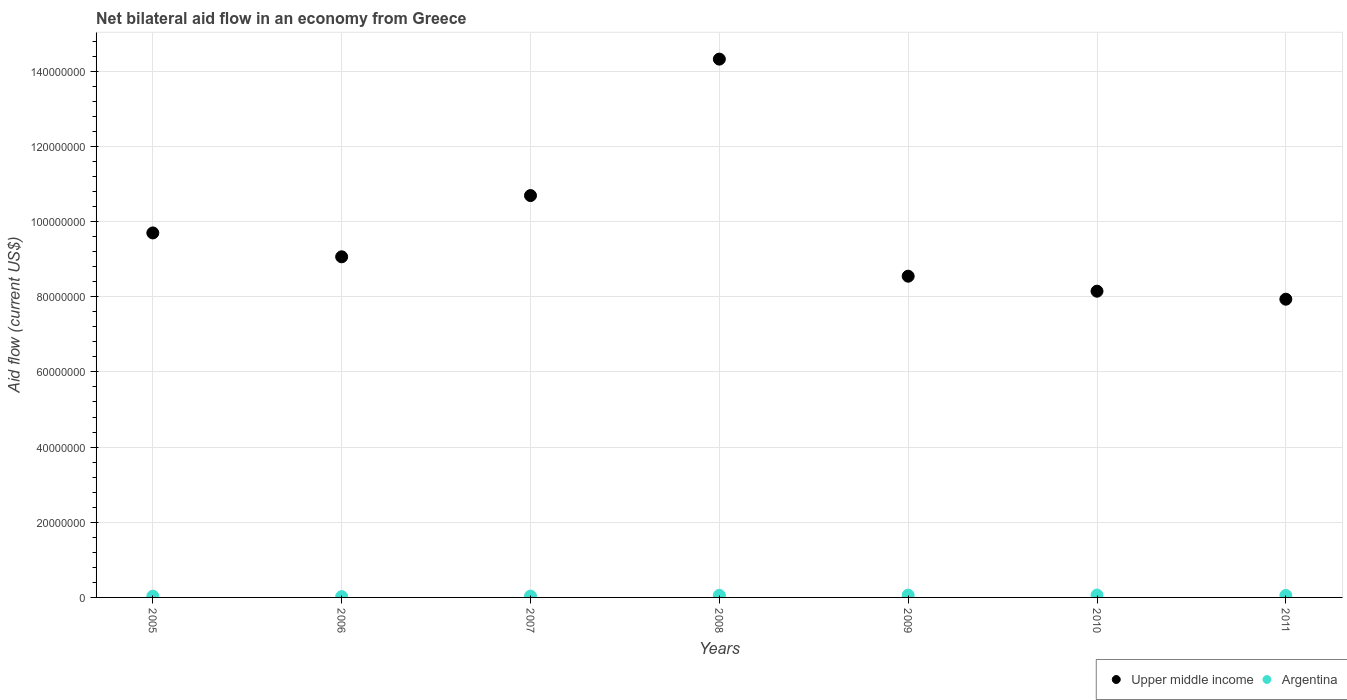Is the number of dotlines equal to the number of legend labels?
Provide a short and direct response. Yes. What is the net bilateral aid flow in Argentina in 2011?
Your answer should be compact. 5.20e+05. Across all years, what is the maximum net bilateral aid flow in Upper middle income?
Give a very brief answer. 1.43e+08. Across all years, what is the minimum net bilateral aid flow in Upper middle income?
Provide a short and direct response. 7.93e+07. What is the total net bilateral aid flow in Argentina in the graph?
Ensure brevity in your answer.  3.20e+06. What is the difference between the net bilateral aid flow in Upper middle income in 2006 and that in 2009?
Provide a succinct answer. 5.16e+06. What is the difference between the net bilateral aid flow in Upper middle income in 2007 and the net bilateral aid flow in Argentina in 2010?
Ensure brevity in your answer.  1.06e+08. What is the average net bilateral aid flow in Upper middle income per year?
Offer a very short reply. 9.77e+07. In the year 2011, what is the difference between the net bilateral aid flow in Argentina and net bilateral aid flow in Upper middle income?
Ensure brevity in your answer.  -7.88e+07. What is the ratio of the net bilateral aid flow in Argentina in 2008 to that in 2009?
Keep it short and to the point. 0.9. Is the difference between the net bilateral aid flow in Argentina in 2009 and 2010 greater than the difference between the net bilateral aid flow in Upper middle income in 2009 and 2010?
Your answer should be compact. No. What is the difference between the highest and the second highest net bilateral aid flow in Upper middle income?
Keep it short and to the point. 3.63e+07. What is the difference between the highest and the lowest net bilateral aid flow in Argentina?
Offer a very short reply. 4.10e+05. In how many years, is the net bilateral aid flow in Argentina greater than the average net bilateral aid flow in Argentina taken over all years?
Your answer should be compact. 4. Is the net bilateral aid flow in Argentina strictly greater than the net bilateral aid flow in Upper middle income over the years?
Offer a very short reply. No. Is the net bilateral aid flow in Upper middle income strictly less than the net bilateral aid flow in Argentina over the years?
Your answer should be compact. No. How many dotlines are there?
Ensure brevity in your answer.  2. How many years are there in the graph?
Your answer should be compact. 7. Does the graph contain any zero values?
Your answer should be very brief. No. What is the title of the graph?
Offer a very short reply. Net bilateral aid flow in an economy from Greece. Does "World" appear as one of the legend labels in the graph?
Your response must be concise. No. What is the label or title of the X-axis?
Your response must be concise. Years. What is the label or title of the Y-axis?
Offer a very short reply. Aid flow (current US$). What is the Aid flow (current US$) of Upper middle income in 2005?
Offer a very short reply. 9.70e+07. What is the Aid flow (current US$) in Upper middle income in 2006?
Provide a short and direct response. 9.06e+07. What is the Aid flow (current US$) in Argentina in 2006?
Your response must be concise. 2.20e+05. What is the Aid flow (current US$) of Upper middle income in 2007?
Ensure brevity in your answer.  1.07e+08. What is the Aid flow (current US$) of Upper middle income in 2008?
Provide a succinct answer. 1.43e+08. What is the Aid flow (current US$) in Upper middle income in 2009?
Your response must be concise. 8.55e+07. What is the Aid flow (current US$) of Argentina in 2009?
Ensure brevity in your answer.  6.10e+05. What is the Aid flow (current US$) in Upper middle income in 2010?
Give a very brief answer. 8.15e+07. What is the Aid flow (current US$) of Argentina in 2010?
Keep it short and to the point. 6.30e+05. What is the Aid flow (current US$) in Upper middle income in 2011?
Keep it short and to the point. 7.93e+07. What is the Aid flow (current US$) in Argentina in 2011?
Provide a short and direct response. 5.20e+05. Across all years, what is the maximum Aid flow (current US$) in Upper middle income?
Your response must be concise. 1.43e+08. Across all years, what is the maximum Aid flow (current US$) of Argentina?
Provide a short and direct response. 6.30e+05. Across all years, what is the minimum Aid flow (current US$) in Upper middle income?
Make the answer very short. 7.93e+07. Across all years, what is the minimum Aid flow (current US$) in Argentina?
Ensure brevity in your answer.  2.20e+05. What is the total Aid flow (current US$) in Upper middle income in the graph?
Your answer should be compact. 6.84e+08. What is the total Aid flow (current US$) in Argentina in the graph?
Ensure brevity in your answer.  3.20e+06. What is the difference between the Aid flow (current US$) of Upper middle income in 2005 and that in 2006?
Your answer should be compact. 6.35e+06. What is the difference between the Aid flow (current US$) of Upper middle income in 2005 and that in 2007?
Your response must be concise. -9.94e+06. What is the difference between the Aid flow (current US$) of Argentina in 2005 and that in 2007?
Make the answer very short. -3.00e+04. What is the difference between the Aid flow (current US$) in Upper middle income in 2005 and that in 2008?
Give a very brief answer. -4.62e+07. What is the difference between the Aid flow (current US$) of Argentina in 2005 and that in 2008?
Give a very brief answer. -2.30e+05. What is the difference between the Aid flow (current US$) in Upper middle income in 2005 and that in 2009?
Your response must be concise. 1.15e+07. What is the difference between the Aid flow (current US$) of Argentina in 2005 and that in 2009?
Your answer should be very brief. -2.90e+05. What is the difference between the Aid flow (current US$) in Upper middle income in 2005 and that in 2010?
Provide a succinct answer. 1.55e+07. What is the difference between the Aid flow (current US$) in Argentina in 2005 and that in 2010?
Offer a very short reply. -3.10e+05. What is the difference between the Aid flow (current US$) in Upper middle income in 2005 and that in 2011?
Make the answer very short. 1.76e+07. What is the difference between the Aid flow (current US$) in Upper middle income in 2006 and that in 2007?
Offer a terse response. -1.63e+07. What is the difference between the Aid flow (current US$) of Upper middle income in 2006 and that in 2008?
Make the answer very short. -5.26e+07. What is the difference between the Aid flow (current US$) of Argentina in 2006 and that in 2008?
Ensure brevity in your answer.  -3.30e+05. What is the difference between the Aid flow (current US$) in Upper middle income in 2006 and that in 2009?
Provide a short and direct response. 5.16e+06. What is the difference between the Aid flow (current US$) in Argentina in 2006 and that in 2009?
Your response must be concise. -3.90e+05. What is the difference between the Aid flow (current US$) of Upper middle income in 2006 and that in 2010?
Provide a short and direct response. 9.15e+06. What is the difference between the Aid flow (current US$) in Argentina in 2006 and that in 2010?
Your response must be concise. -4.10e+05. What is the difference between the Aid flow (current US$) in Upper middle income in 2006 and that in 2011?
Your answer should be compact. 1.13e+07. What is the difference between the Aid flow (current US$) in Upper middle income in 2007 and that in 2008?
Offer a terse response. -3.63e+07. What is the difference between the Aid flow (current US$) in Argentina in 2007 and that in 2008?
Your answer should be very brief. -2.00e+05. What is the difference between the Aid flow (current US$) in Upper middle income in 2007 and that in 2009?
Your answer should be compact. 2.14e+07. What is the difference between the Aid flow (current US$) of Argentina in 2007 and that in 2009?
Provide a succinct answer. -2.60e+05. What is the difference between the Aid flow (current US$) of Upper middle income in 2007 and that in 2010?
Your response must be concise. 2.54e+07. What is the difference between the Aid flow (current US$) of Argentina in 2007 and that in 2010?
Offer a terse response. -2.80e+05. What is the difference between the Aid flow (current US$) of Upper middle income in 2007 and that in 2011?
Your response must be concise. 2.76e+07. What is the difference between the Aid flow (current US$) of Argentina in 2007 and that in 2011?
Your response must be concise. -1.70e+05. What is the difference between the Aid flow (current US$) in Upper middle income in 2008 and that in 2009?
Your response must be concise. 5.78e+07. What is the difference between the Aid flow (current US$) in Argentina in 2008 and that in 2009?
Your answer should be compact. -6.00e+04. What is the difference between the Aid flow (current US$) of Upper middle income in 2008 and that in 2010?
Offer a very short reply. 6.17e+07. What is the difference between the Aid flow (current US$) of Argentina in 2008 and that in 2010?
Your answer should be very brief. -8.00e+04. What is the difference between the Aid flow (current US$) of Upper middle income in 2008 and that in 2011?
Provide a short and direct response. 6.39e+07. What is the difference between the Aid flow (current US$) in Upper middle income in 2009 and that in 2010?
Offer a very short reply. 3.99e+06. What is the difference between the Aid flow (current US$) of Upper middle income in 2009 and that in 2011?
Make the answer very short. 6.12e+06. What is the difference between the Aid flow (current US$) in Upper middle income in 2010 and that in 2011?
Make the answer very short. 2.13e+06. What is the difference between the Aid flow (current US$) in Upper middle income in 2005 and the Aid flow (current US$) in Argentina in 2006?
Offer a very short reply. 9.68e+07. What is the difference between the Aid flow (current US$) of Upper middle income in 2005 and the Aid flow (current US$) of Argentina in 2007?
Ensure brevity in your answer.  9.66e+07. What is the difference between the Aid flow (current US$) in Upper middle income in 2005 and the Aid flow (current US$) in Argentina in 2008?
Give a very brief answer. 9.64e+07. What is the difference between the Aid flow (current US$) of Upper middle income in 2005 and the Aid flow (current US$) of Argentina in 2009?
Make the answer very short. 9.64e+07. What is the difference between the Aid flow (current US$) in Upper middle income in 2005 and the Aid flow (current US$) in Argentina in 2010?
Provide a short and direct response. 9.63e+07. What is the difference between the Aid flow (current US$) of Upper middle income in 2005 and the Aid flow (current US$) of Argentina in 2011?
Offer a terse response. 9.64e+07. What is the difference between the Aid flow (current US$) of Upper middle income in 2006 and the Aid flow (current US$) of Argentina in 2007?
Your answer should be compact. 9.03e+07. What is the difference between the Aid flow (current US$) of Upper middle income in 2006 and the Aid flow (current US$) of Argentina in 2008?
Provide a succinct answer. 9.01e+07. What is the difference between the Aid flow (current US$) in Upper middle income in 2006 and the Aid flow (current US$) in Argentina in 2009?
Give a very brief answer. 9.00e+07. What is the difference between the Aid flow (current US$) in Upper middle income in 2006 and the Aid flow (current US$) in Argentina in 2010?
Offer a terse response. 9.00e+07. What is the difference between the Aid flow (current US$) in Upper middle income in 2006 and the Aid flow (current US$) in Argentina in 2011?
Your answer should be compact. 9.01e+07. What is the difference between the Aid flow (current US$) of Upper middle income in 2007 and the Aid flow (current US$) of Argentina in 2008?
Give a very brief answer. 1.06e+08. What is the difference between the Aid flow (current US$) in Upper middle income in 2007 and the Aid flow (current US$) in Argentina in 2009?
Give a very brief answer. 1.06e+08. What is the difference between the Aid flow (current US$) in Upper middle income in 2007 and the Aid flow (current US$) in Argentina in 2010?
Your response must be concise. 1.06e+08. What is the difference between the Aid flow (current US$) of Upper middle income in 2007 and the Aid flow (current US$) of Argentina in 2011?
Your answer should be very brief. 1.06e+08. What is the difference between the Aid flow (current US$) of Upper middle income in 2008 and the Aid flow (current US$) of Argentina in 2009?
Keep it short and to the point. 1.43e+08. What is the difference between the Aid flow (current US$) in Upper middle income in 2008 and the Aid flow (current US$) in Argentina in 2010?
Your answer should be compact. 1.43e+08. What is the difference between the Aid flow (current US$) in Upper middle income in 2008 and the Aid flow (current US$) in Argentina in 2011?
Keep it short and to the point. 1.43e+08. What is the difference between the Aid flow (current US$) in Upper middle income in 2009 and the Aid flow (current US$) in Argentina in 2010?
Keep it short and to the point. 8.48e+07. What is the difference between the Aid flow (current US$) of Upper middle income in 2009 and the Aid flow (current US$) of Argentina in 2011?
Offer a terse response. 8.49e+07. What is the difference between the Aid flow (current US$) in Upper middle income in 2010 and the Aid flow (current US$) in Argentina in 2011?
Offer a terse response. 8.10e+07. What is the average Aid flow (current US$) of Upper middle income per year?
Offer a very short reply. 9.77e+07. What is the average Aid flow (current US$) in Argentina per year?
Ensure brevity in your answer.  4.57e+05. In the year 2005, what is the difference between the Aid flow (current US$) of Upper middle income and Aid flow (current US$) of Argentina?
Provide a succinct answer. 9.66e+07. In the year 2006, what is the difference between the Aid flow (current US$) of Upper middle income and Aid flow (current US$) of Argentina?
Keep it short and to the point. 9.04e+07. In the year 2007, what is the difference between the Aid flow (current US$) of Upper middle income and Aid flow (current US$) of Argentina?
Offer a terse response. 1.07e+08. In the year 2008, what is the difference between the Aid flow (current US$) in Upper middle income and Aid flow (current US$) in Argentina?
Offer a very short reply. 1.43e+08. In the year 2009, what is the difference between the Aid flow (current US$) of Upper middle income and Aid flow (current US$) of Argentina?
Give a very brief answer. 8.48e+07. In the year 2010, what is the difference between the Aid flow (current US$) of Upper middle income and Aid flow (current US$) of Argentina?
Your answer should be compact. 8.08e+07. In the year 2011, what is the difference between the Aid flow (current US$) of Upper middle income and Aid flow (current US$) of Argentina?
Keep it short and to the point. 7.88e+07. What is the ratio of the Aid flow (current US$) in Upper middle income in 2005 to that in 2006?
Offer a very short reply. 1.07. What is the ratio of the Aid flow (current US$) of Argentina in 2005 to that in 2006?
Your answer should be very brief. 1.45. What is the ratio of the Aid flow (current US$) of Upper middle income in 2005 to that in 2007?
Offer a very short reply. 0.91. What is the ratio of the Aid flow (current US$) in Argentina in 2005 to that in 2007?
Provide a succinct answer. 0.91. What is the ratio of the Aid flow (current US$) in Upper middle income in 2005 to that in 2008?
Ensure brevity in your answer.  0.68. What is the ratio of the Aid flow (current US$) of Argentina in 2005 to that in 2008?
Provide a succinct answer. 0.58. What is the ratio of the Aid flow (current US$) of Upper middle income in 2005 to that in 2009?
Make the answer very short. 1.13. What is the ratio of the Aid flow (current US$) in Argentina in 2005 to that in 2009?
Ensure brevity in your answer.  0.52. What is the ratio of the Aid flow (current US$) in Upper middle income in 2005 to that in 2010?
Your response must be concise. 1.19. What is the ratio of the Aid flow (current US$) of Argentina in 2005 to that in 2010?
Your answer should be compact. 0.51. What is the ratio of the Aid flow (current US$) in Upper middle income in 2005 to that in 2011?
Your answer should be very brief. 1.22. What is the ratio of the Aid flow (current US$) of Argentina in 2005 to that in 2011?
Your response must be concise. 0.62. What is the ratio of the Aid flow (current US$) in Upper middle income in 2006 to that in 2007?
Provide a short and direct response. 0.85. What is the ratio of the Aid flow (current US$) in Argentina in 2006 to that in 2007?
Your answer should be compact. 0.63. What is the ratio of the Aid flow (current US$) in Upper middle income in 2006 to that in 2008?
Ensure brevity in your answer.  0.63. What is the ratio of the Aid flow (current US$) in Argentina in 2006 to that in 2008?
Offer a very short reply. 0.4. What is the ratio of the Aid flow (current US$) of Upper middle income in 2006 to that in 2009?
Ensure brevity in your answer.  1.06. What is the ratio of the Aid flow (current US$) of Argentina in 2006 to that in 2009?
Provide a short and direct response. 0.36. What is the ratio of the Aid flow (current US$) in Upper middle income in 2006 to that in 2010?
Offer a very short reply. 1.11. What is the ratio of the Aid flow (current US$) in Argentina in 2006 to that in 2010?
Provide a succinct answer. 0.35. What is the ratio of the Aid flow (current US$) of Upper middle income in 2006 to that in 2011?
Offer a terse response. 1.14. What is the ratio of the Aid flow (current US$) in Argentina in 2006 to that in 2011?
Your answer should be very brief. 0.42. What is the ratio of the Aid flow (current US$) of Upper middle income in 2007 to that in 2008?
Provide a succinct answer. 0.75. What is the ratio of the Aid flow (current US$) in Argentina in 2007 to that in 2008?
Your response must be concise. 0.64. What is the ratio of the Aid flow (current US$) of Upper middle income in 2007 to that in 2009?
Keep it short and to the point. 1.25. What is the ratio of the Aid flow (current US$) in Argentina in 2007 to that in 2009?
Your answer should be very brief. 0.57. What is the ratio of the Aid flow (current US$) in Upper middle income in 2007 to that in 2010?
Provide a short and direct response. 1.31. What is the ratio of the Aid flow (current US$) of Argentina in 2007 to that in 2010?
Offer a very short reply. 0.56. What is the ratio of the Aid flow (current US$) in Upper middle income in 2007 to that in 2011?
Your answer should be compact. 1.35. What is the ratio of the Aid flow (current US$) in Argentina in 2007 to that in 2011?
Your response must be concise. 0.67. What is the ratio of the Aid flow (current US$) of Upper middle income in 2008 to that in 2009?
Your response must be concise. 1.68. What is the ratio of the Aid flow (current US$) of Argentina in 2008 to that in 2009?
Your answer should be very brief. 0.9. What is the ratio of the Aid flow (current US$) in Upper middle income in 2008 to that in 2010?
Give a very brief answer. 1.76. What is the ratio of the Aid flow (current US$) in Argentina in 2008 to that in 2010?
Give a very brief answer. 0.87. What is the ratio of the Aid flow (current US$) in Upper middle income in 2008 to that in 2011?
Offer a terse response. 1.8. What is the ratio of the Aid flow (current US$) in Argentina in 2008 to that in 2011?
Make the answer very short. 1.06. What is the ratio of the Aid flow (current US$) of Upper middle income in 2009 to that in 2010?
Offer a very short reply. 1.05. What is the ratio of the Aid flow (current US$) in Argentina in 2009 to that in 2010?
Your response must be concise. 0.97. What is the ratio of the Aid flow (current US$) of Upper middle income in 2009 to that in 2011?
Provide a succinct answer. 1.08. What is the ratio of the Aid flow (current US$) of Argentina in 2009 to that in 2011?
Ensure brevity in your answer.  1.17. What is the ratio of the Aid flow (current US$) in Upper middle income in 2010 to that in 2011?
Your answer should be very brief. 1.03. What is the ratio of the Aid flow (current US$) in Argentina in 2010 to that in 2011?
Your answer should be very brief. 1.21. What is the difference between the highest and the second highest Aid flow (current US$) of Upper middle income?
Offer a very short reply. 3.63e+07. What is the difference between the highest and the lowest Aid flow (current US$) of Upper middle income?
Your response must be concise. 6.39e+07. 